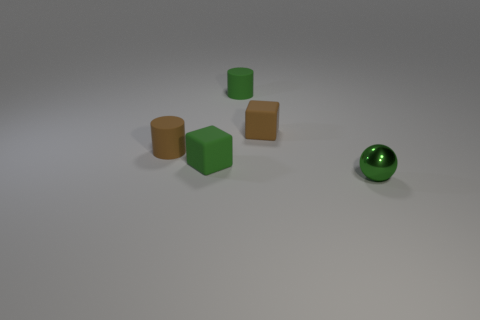Add 4 small green rubber cylinders. How many objects exist? 9 Subtract all cylinders. How many objects are left? 3 Subtract all brown cylinders. How many cylinders are left? 1 Subtract 1 blocks. How many blocks are left? 1 Add 2 small matte cubes. How many small matte cubes are left? 4 Add 4 green matte blocks. How many green matte blocks exist? 5 Subtract 1 green cubes. How many objects are left? 4 Subtract all yellow blocks. Subtract all red balls. How many blocks are left? 2 Subtract all tiny yellow rubber balls. Subtract all small green objects. How many objects are left? 2 